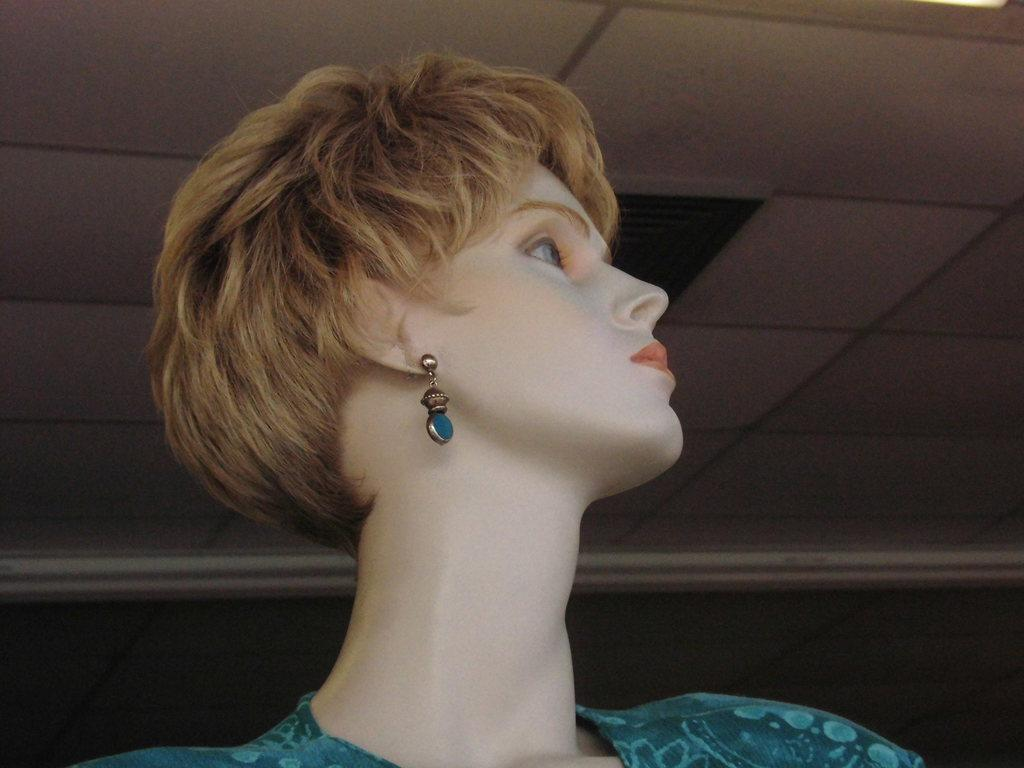What is the main subject of the image? There is a statue in the image. How many hands do the giants have in the image? There are no giants present in the image, and therefore no hands to count. What type of trucks can be seen in the image? There are no trucks present in the image. 